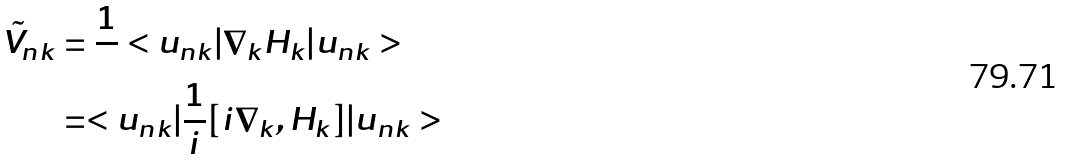<formula> <loc_0><loc_0><loc_500><loc_500>\tilde { V } _ { n k } & = \frac { 1 } { } < u _ { n k } | \nabla _ { k } H _ { k } | u _ { n k } > \\ & = < u _ { n k } | \frac { 1 } { i } [ i \nabla _ { k } , H _ { k } ] | u _ { n k } > \\</formula> 